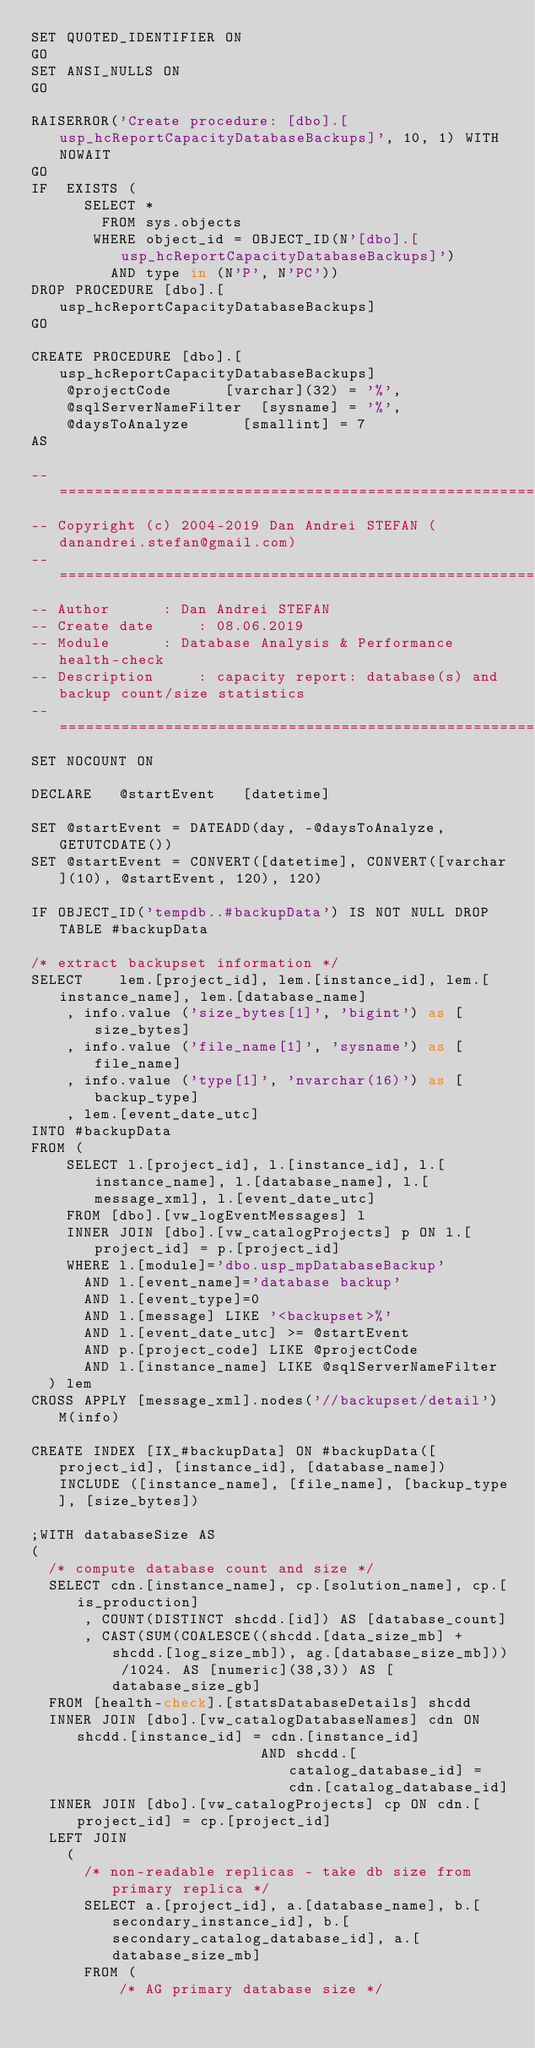Convert code to text. <code><loc_0><loc_0><loc_500><loc_500><_SQL_>SET QUOTED_IDENTIFIER ON 
GO
SET ANSI_NULLS ON 
GO

RAISERROR('Create procedure: [dbo].[usp_hcReportCapacityDatabaseBackups]', 10, 1) WITH NOWAIT
GO
IF  EXISTS (
	    SELECT * 
	      FROM sys.objects 
	     WHERE object_id = OBJECT_ID(N'[dbo].[usp_hcReportCapacityDatabaseBackups]') 
	       AND type in (N'P', N'PC'))
DROP PROCEDURE [dbo].[usp_hcReportCapacityDatabaseBackups]
GO

CREATE PROCEDURE [dbo].[usp_hcReportCapacityDatabaseBackups]
		@projectCode			[varchar](32) = '%',
		@sqlServerNameFilter	[sysname] = '%',
		@daysToAnalyze			[smallint] = 7
AS

-- ============================================================================
-- Copyright (c) 2004-2019 Dan Andrei STEFAN (danandrei.stefan@gmail.com)
-- ============================================================================
-- Author			 : Dan Andrei STEFAN
-- Create date		 : 08.06.2019
-- Module			 : Database Analysis & Performance health-check
-- Description		 : capacity report: database(s) and backup count/size statistics 
-- ============================================================================
SET NOCOUNT ON

DECLARE   @startEvent		[datetime]

SET @startEvent = DATEADD(day, -@daysToAnalyze, GETUTCDATE())
SET @startEvent = CONVERT([datetime], CONVERT([varchar](10), @startEvent, 120), 120)

IF OBJECT_ID('tempdb..#backupData') IS NOT NULL DROP TABLE #backupData

/* extract backupset information */
SELECT	  lem.[project_id], lem.[instance_id], lem.[instance_name], lem.[database_name]
		, info.value ('size_bytes[1]', 'bigint') as [size_bytes]
		, info.value ('file_name[1]', 'sysname') as [file_name]
		, info.value ('type[1]', 'nvarchar(16)') as [backup_type]
		, lem.[event_date_utc]
INTO #backupData
FROM (
		SELECT l.[project_id], l.[instance_id], l.[instance_name], l.[database_name], l.[message_xml], l.[event_date_utc]
		FROM [dbo].[vw_logEventMessages] l
		INNER JOIN [dbo].[vw_catalogProjects] p ON l.[project_id] = p.[project_id]
		WHERE l.[module]='dbo.usp_mpDatabaseBackup'
			AND l.[event_name]='database backup'
			AND l.[event_type]=0
			AND l.[message] LIKE '<backupset>%'
			AND l.[event_date_utc] >= @startEvent
			AND p.[project_code] LIKE @projectCode
			AND l.[instance_name] LIKE @sqlServerNameFilter
	) lem
CROSS APPLY [message_xml].nodes('//backupset/detail') M(info)

CREATE INDEX [IX_#backupData] ON #backupData([project_id], [instance_id], [database_name]) INCLUDE ([instance_name], [file_name], [backup_type], [size_bytes])

;WITH databaseSize AS
(
	/* compute database count and size */
	SELECT cdn.[instance_name], cp.[solution_name], cp.[is_production]
			, COUNT(DISTINCT shcdd.[id]) AS [database_count]
			, CAST(SUM(COALESCE((shcdd.[data_size_mb] + shcdd.[log_size_mb]), ag.[database_size_mb])) /1024. AS [numeric](38,3)) AS [database_size_gb]
	FROM [health-check].[statsDatabaseDetails] shcdd
	INNER JOIN [dbo].[vw_catalogDatabaseNames] cdn ON	shcdd.[instance_id] = cdn.[instance_id]
													AND shcdd.[catalog_database_id] = cdn.[catalog_database_id]
	INNER JOIN [dbo].[vw_catalogProjects] cp ON cdn.[project_id] = cp.[project_id]
	LEFT JOIN
		(
			/* non-readable replicas - take db size from primary replica */
			SELECT a.[project_id], a.[database_name], b.[secondary_instance_id], b.[secondary_catalog_database_id], a.[database_size_mb]
			FROM (
					/* AG primary database size */</code> 